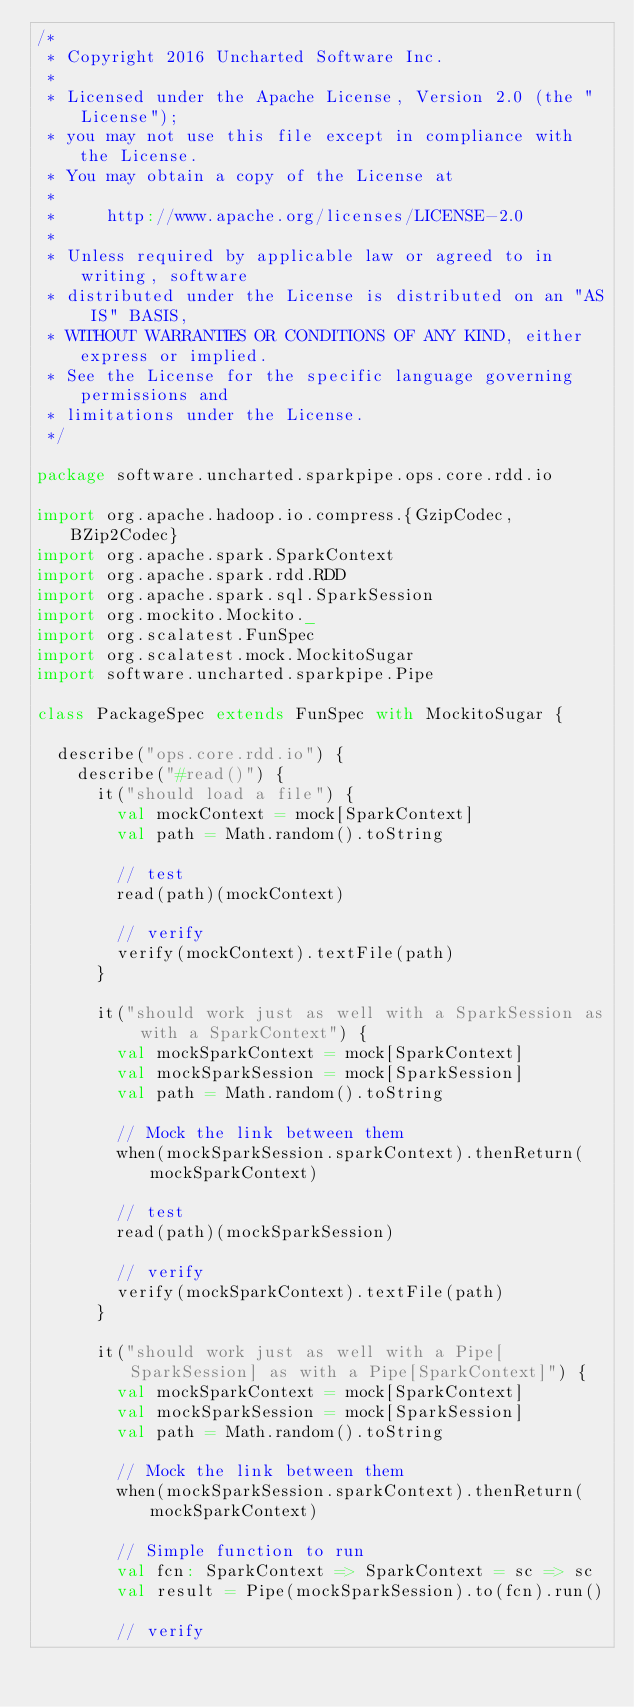Convert code to text. <code><loc_0><loc_0><loc_500><loc_500><_Scala_>/*
 * Copyright 2016 Uncharted Software Inc.
 *
 * Licensed under the Apache License, Version 2.0 (the "License");
 * you may not use this file except in compliance with the License.
 * You may obtain a copy of the License at
 *
 *     http://www.apache.org/licenses/LICENSE-2.0
 *
 * Unless required by applicable law or agreed to in writing, software
 * distributed under the License is distributed on an "AS IS" BASIS,
 * WITHOUT WARRANTIES OR CONDITIONS OF ANY KIND, either express or implied.
 * See the License for the specific language governing permissions and
 * limitations under the License.
 */

package software.uncharted.sparkpipe.ops.core.rdd.io

import org.apache.hadoop.io.compress.{GzipCodec, BZip2Codec}
import org.apache.spark.SparkContext
import org.apache.spark.rdd.RDD
import org.apache.spark.sql.SparkSession
import org.mockito.Mockito._
import org.scalatest.FunSpec
import org.scalatest.mock.MockitoSugar
import software.uncharted.sparkpipe.Pipe

class PackageSpec extends FunSpec with MockitoSugar {

  describe("ops.core.rdd.io") {
    describe("#read()") {
      it("should load a file") {
        val mockContext = mock[SparkContext]
        val path = Math.random().toString

        // test
        read(path)(mockContext)

        // verify
        verify(mockContext).textFile(path)
      }

      it("should work just as well with a SparkSession as with a SparkContext") {
        val mockSparkContext = mock[SparkContext]
        val mockSparkSession = mock[SparkSession]
        val path = Math.random().toString

        // Mock the link between them
        when(mockSparkSession.sparkContext).thenReturn(mockSparkContext)

        // test
        read(path)(mockSparkSession)

        // verify
        verify(mockSparkContext).textFile(path)
      }

      it("should work just as well with a Pipe[SparkSession] as with a Pipe[SparkContext]") {
        val mockSparkContext = mock[SparkContext]
        val mockSparkSession = mock[SparkSession]
        val path = Math.random().toString

        // Mock the link between them
        when(mockSparkSession.sparkContext).thenReturn(mockSparkContext)

        // Simple function to run
        val fcn: SparkContext => SparkContext = sc => sc
        val result = Pipe(mockSparkSession).to(fcn).run()

        // verify</code> 